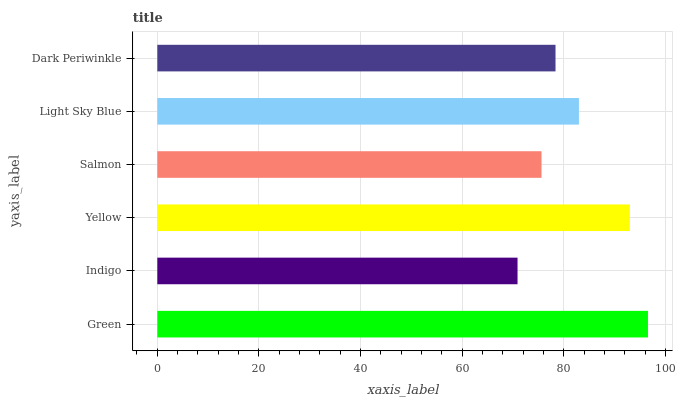Is Indigo the minimum?
Answer yes or no. Yes. Is Green the maximum?
Answer yes or no. Yes. Is Yellow the minimum?
Answer yes or no. No. Is Yellow the maximum?
Answer yes or no. No. Is Yellow greater than Indigo?
Answer yes or no. Yes. Is Indigo less than Yellow?
Answer yes or no. Yes. Is Indigo greater than Yellow?
Answer yes or no. No. Is Yellow less than Indigo?
Answer yes or no. No. Is Light Sky Blue the high median?
Answer yes or no. Yes. Is Dark Periwinkle the low median?
Answer yes or no. Yes. Is Salmon the high median?
Answer yes or no. No. Is Indigo the low median?
Answer yes or no. No. 